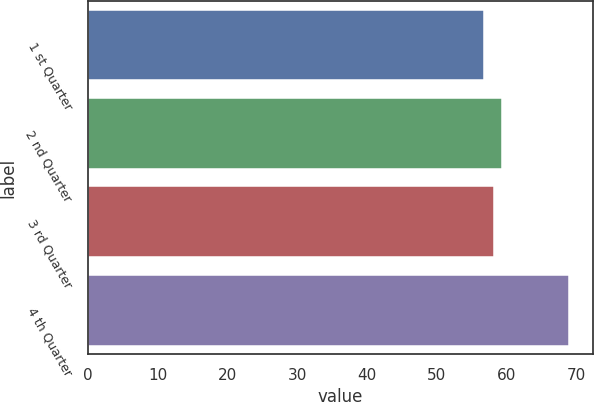Convert chart to OTSL. <chart><loc_0><loc_0><loc_500><loc_500><bar_chart><fcel>1 st Quarter<fcel>2 nd Quarter<fcel>3 rd Quarter<fcel>4 th Quarter<nl><fcel>56.68<fcel>59.34<fcel>58.12<fcel>68.92<nl></chart> 